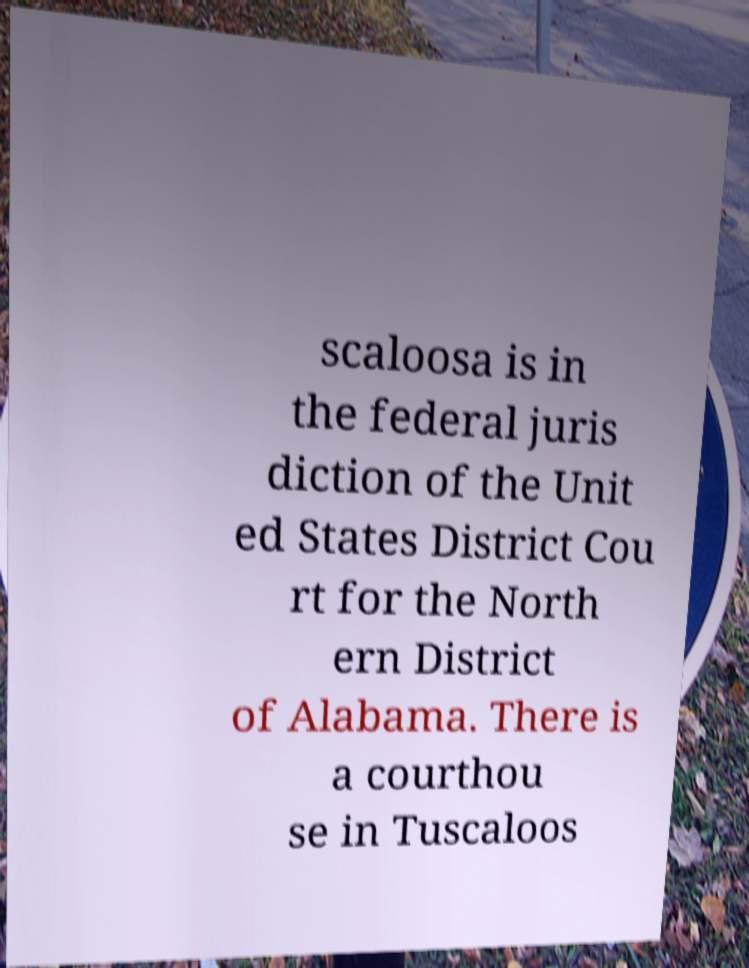Could you extract and type out the text from this image? scaloosa is in the federal juris diction of the Unit ed States District Cou rt for the North ern District of Alabama. There is a courthou se in Tuscaloos 